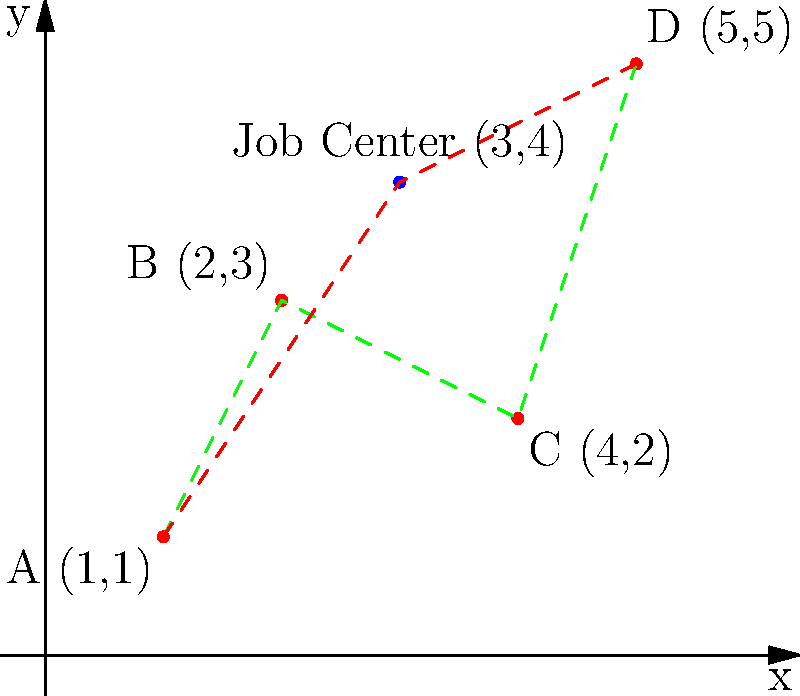A local job center offers employment opportunities for homeless individuals. The coordinate system shows different bus stops (A, B, C, D) and the job center. Two bus routes are available: the green route (A-B-C-D) and the red route (A-Job Center-D). Which route should you take to reach the job center most efficiently, and what is the total distance traveled? To solve this problem, we need to calculate the distances for both routes and compare them:

1. Green route (A-B-C-D):
   - A to B: $\sqrt{(2-1)^2 + (3-1)^2} = \sqrt{5}$
   - B to C: $\sqrt{(4-2)^2 + (2-3)^2} = \sqrt{5}$
   - C to Job Center: $\sqrt{(3-4)^2 + (4-2)^2} = \sqrt{5}$
   Total distance: $\sqrt{5} + \sqrt{5} + \sqrt{5} = 3\sqrt{5}$

2. Red route (A-Job Center-D):
   - A to Job Center: $\sqrt{(3-1)^2 + (4-1)^2} = \sqrt{13}$
   Total distance: $\sqrt{13}$

3. Compare the distances:
   $3\sqrt{5} \approx 6.71$ and $\sqrt{13} \approx 3.61$

The red route (A-Job Center) is shorter and more efficient.
Answer: Red route, $\sqrt{13}$ units 